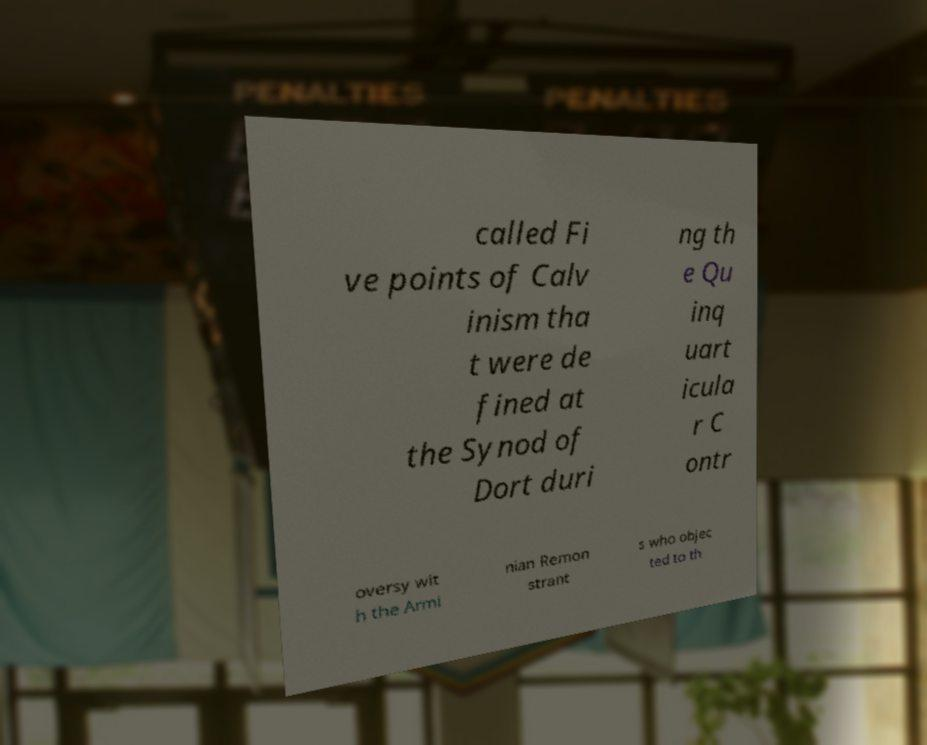There's text embedded in this image that I need extracted. Can you transcribe it verbatim? called Fi ve points of Calv inism tha t were de fined at the Synod of Dort duri ng th e Qu inq uart icula r C ontr oversy wit h the Armi nian Remon strant s who objec ted to th 